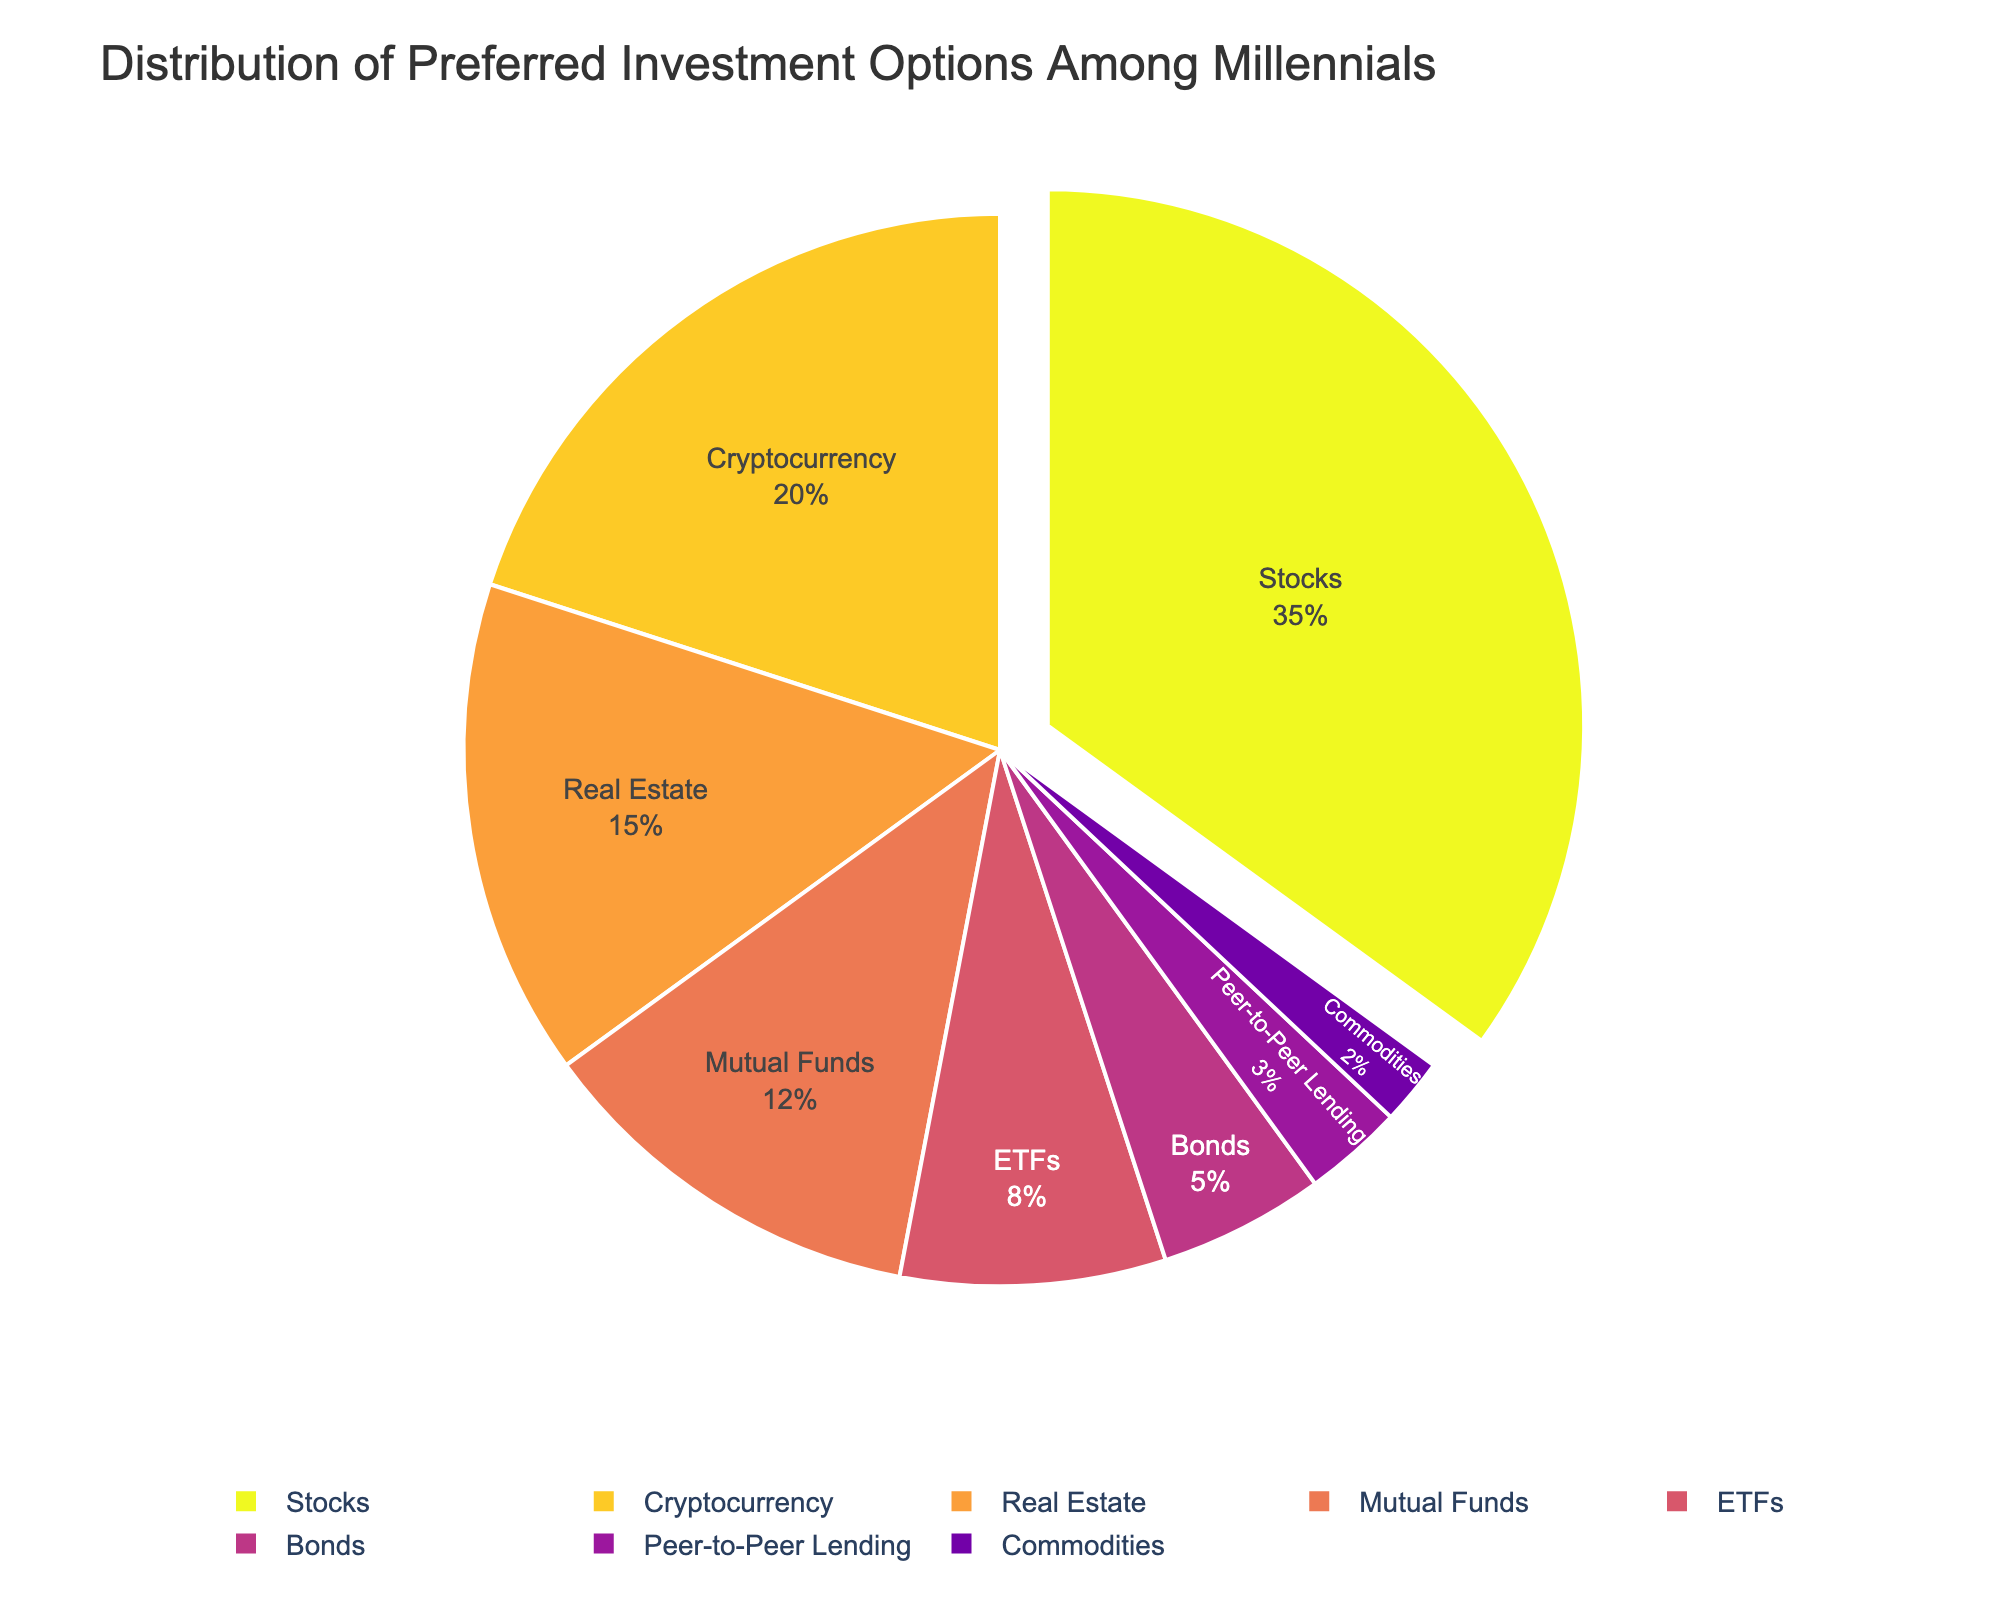What is the most preferred investment option among millennials? The largest segment in the pie chart represents the most preferred investment option. The "Stocks" segment is the largest, indicating that most millennials prefer investing in stocks.
Answer: Stocks Which investment option has the smallest percentage? The smallest segment in the pie chart represents the investment option with the smallest percentage. "Commodities" has the smallest segment, indicating it is the least preferred.
Answer: Commodities How much more popular are stocks compared to bonds? The percentage of stocks (35%) minus the percentage of bonds (5%) gives the difference in popularity.
Answer: 30% What is the combined percentage of people who prefer mutual funds and ETFs? Adding the percentage of mutual funds (12%) and ETFs (8%) gives the combined percentage.
Answer: 20% Is cryptocurrency more popular than real estate among millennials? The segment for cryptocurrency (20%) is larger than the segment for real estate (15%), indicating cryptocurrency is more popular.
Answer: Yes How much more popular is peer-to-peer lending compared to commodities? The percentage of peer-to-peer lending (3%) minus the percentage of commodities (2%) gives the difference.
Answer: 1% Which two investment options combined make up exactly half of the total preferences? Adding the percentages of stocks (35%) and cryptocurrency (20%) gives a total of 55%, and checking other combinations, none directly sums to 50%. Therefore, no two options make exactly half.
Answer: None What is the average percentage for the top three investment options? Averaging the percentages of stocks (35%), cryptocurrency (20%), and real estate (15%) involves summing them up (35 + 20 + 15 = 70) and dividing by 3.
Answer: 23.33% Which investment option appears in dark color and is in the middle of the chart? Visually identifying the segment's position and color, mutual funds appear in a dark color near the center.
Answer: Mutual Funds 